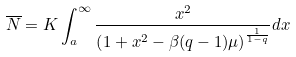<formula> <loc_0><loc_0><loc_500><loc_500>\overline { N } = K \int _ { a } ^ { \infty } \frac { x ^ { 2 } } { \left ( 1 + x ^ { 2 } - \beta ( q - 1 ) \mu \right ) ^ { \frac { 1 } { 1 - q } } } d x</formula> 